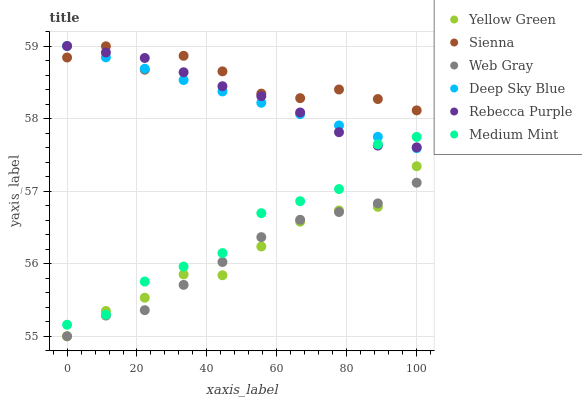Does Web Gray have the minimum area under the curve?
Answer yes or no. Yes. Does Sienna have the maximum area under the curve?
Answer yes or no. Yes. Does Yellow Green have the minimum area under the curve?
Answer yes or no. No. Does Yellow Green have the maximum area under the curve?
Answer yes or no. No. Is Deep Sky Blue the smoothest?
Answer yes or no. Yes. Is Medium Mint the roughest?
Answer yes or no. Yes. Is Web Gray the smoothest?
Answer yes or no. No. Is Web Gray the roughest?
Answer yes or no. No. Does Web Gray have the lowest value?
Answer yes or no. Yes. Does Sienna have the lowest value?
Answer yes or no. No. Does Deep Sky Blue have the highest value?
Answer yes or no. Yes. Does Yellow Green have the highest value?
Answer yes or no. No. Is Medium Mint less than Sienna?
Answer yes or no. Yes. Is Medium Mint greater than Web Gray?
Answer yes or no. Yes. Does Sienna intersect Rebecca Purple?
Answer yes or no. Yes. Is Sienna less than Rebecca Purple?
Answer yes or no. No. Is Sienna greater than Rebecca Purple?
Answer yes or no. No. Does Medium Mint intersect Sienna?
Answer yes or no. No. 